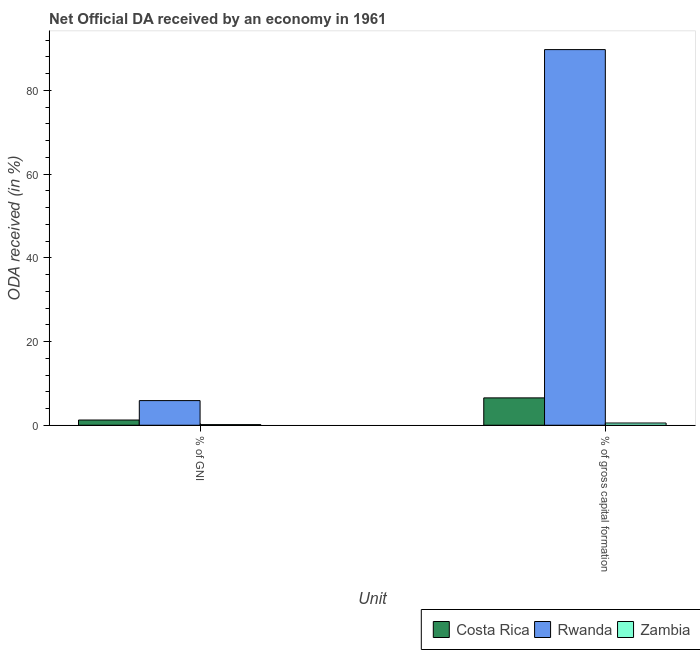How many bars are there on the 2nd tick from the left?
Ensure brevity in your answer.  3. What is the label of the 1st group of bars from the left?
Your response must be concise. % of GNI. What is the oda received as percentage of gross capital formation in Costa Rica?
Provide a short and direct response. 6.54. Across all countries, what is the maximum oda received as percentage of gni?
Make the answer very short. 5.89. Across all countries, what is the minimum oda received as percentage of gni?
Ensure brevity in your answer.  0.15. In which country was the oda received as percentage of gni maximum?
Give a very brief answer. Rwanda. In which country was the oda received as percentage of gross capital formation minimum?
Provide a short and direct response. Zambia. What is the total oda received as percentage of gross capital formation in the graph?
Provide a succinct answer. 96.82. What is the difference between the oda received as percentage of gni in Costa Rica and that in Zambia?
Offer a very short reply. 1.1. What is the difference between the oda received as percentage of gross capital formation in Costa Rica and the oda received as percentage of gni in Rwanda?
Ensure brevity in your answer.  0.65. What is the average oda received as percentage of gross capital formation per country?
Keep it short and to the point. 32.27. What is the difference between the oda received as percentage of gross capital formation and oda received as percentage of gni in Costa Rica?
Provide a short and direct response. 5.29. In how many countries, is the oda received as percentage of gross capital formation greater than 48 %?
Offer a very short reply. 1. What is the ratio of the oda received as percentage of gross capital formation in Costa Rica to that in Zambia?
Ensure brevity in your answer.  12.23. What does the 1st bar from the left in % of gross capital formation represents?
Give a very brief answer. Costa Rica. How many countries are there in the graph?
Provide a succinct answer. 3. Are the values on the major ticks of Y-axis written in scientific E-notation?
Your response must be concise. No. Where does the legend appear in the graph?
Your response must be concise. Bottom right. What is the title of the graph?
Give a very brief answer. Net Official DA received by an economy in 1961. What is the label or title of the X-axis?
Provide a succinct answer. Unit. What is the label or title of the Y-axis?
Ensure brevity in your answer.  ODA received (in %). What is the ODA received (in %) in Costa Rica in % of GNI?
Keep it short and to the point. 1.25. What is the ODA received (in %) of Rwanda in % of GNI?
Ensure brevity in your answer.  5.89. What is the ODA received (in %) of Zambia in % of GNI?
Your answer should be compact. 0.15. What is the ODA received (in %) in Costa Rica in % of gross capital formation?
Offer a very short reply. 6.54. What is the ODA received (in %) in Rwanda in % of gross capital formation?
Your answer should be compact. 89.75. What is the ODA received (in %) in Zambia in % of gross capital formation?
Ensure brevity in your answer.  0.53. Across all Unit, what is the maximum ODA received (in %) of Costa Rica?
Your answer should be very brief. 6.54. Across all Unit, what is the maximum ODA received (in %) in Rwanda?
Your answer should be very brief. 89.75. Across all Unit, what is the maximum ODA received (in %) of Zambia?
Offer a very short reply. 0.53. Across all Unit, what is the minimum ODA received (in %) of Costa Rica?
Your response must be concise. 1.25. Across all Unit, what is the minimum ODA received (in %) in Rwanda?
Ensure brevity in your answer.  5.89. Across all Unit, what is the minimum ODA received (in %) in Zambia?
Provide a short and direct response. 0.15. What is the total ODA received (in %) in Costa Rica in the graph?
Your answer should be very brief. 7.78. What is the total ODA received (in %) of Rwanda in the graph?
Your answer should be very brief. 95.64. What is the total ODA received (in %) of Zambia in the graph?
Keep it short and to the point. 0.68. What is the difference between the ODA received (in %) in Costa Rica in % of GNI and that in % of gross capital formation?
Make the answer very short. -5.29. What is the difference between the ODA received (in %) of Rwanda in % of GNI and that in % of gross capital formation?
Keep it short and to the point. -83.86. What is the difference between the ODA received (in %) of Zambia in % of GNI and that in % of gross capital formation?
Your answer should be very brief. -0.39. What is the difference between the ODA received (in %) of Costa Rica in % of GNI and the ODA received (in %) of Rwanda in % of gross capital formation?
Give a very brief answer. -88.5. What is the difference between the ODA received (in %) of Costa Rica in % of GNI and the ODA received (in %) of Zambia in % of gross capital formation?
Make the answer very short. 0.71. What is the difference between the ODA received (in %) in Rwanda in % of GNI and the ODA received (in %) in Zambia in % of gross capital formation?
Ensure brevity in your answer.  5.35. What is the average ODA received (in %) in Costa Rica per Unit?
Your answer should be compact. 3.89. What is the average ODA received (in %) of Rwanda per Unit?
Your answer should be compact. 47.82. What is the average ODA received (in %) of Zambia per Unit?
Provide a short and direct response. 0.34. What is the difference between the ODA received (in %) of Costa Rica and ODA received (in %) of Rwanda in % of GNI?
Ensure brevity in your answer.  -4.64. What is the difference between the ODA received (in %) of Costa Rica and ODA received (in %) of Zambia in % of GNI?
Provide a succinct answer. 1.1. What is the difference between the ODA received (in %) in Rwanda and ODA received (in %) in Zambia in % of GNI?
Your answer should be compact. 5.74. What is the difference between the ODA received (in %) in Costa Rica and ODA received (in %) in Rwanda in % of gross capital formation?
Your answer should be very brief. -83.21. What is the difference between the ODA received (in %) in Costa Rica and ODA received (in %) in Zambia in % of gross capital formation?
Give a very brief answer. 6. What is the difference between the ODA received (in %) of Rwanda and ODA received (in %) of Zambia in % of gross capital formation?
Provide a short and direct response. 89.22. What is the ratio of the ODA received (in %) of Costa Rica in % of GNI to that in % of gross capital formation?
Offer a terse response. 0.19. What is the ratio of the ODA received (in %) in Rwanda in % of GNI to that in % of gross capital formation?
Offer a terse response. 0.07. What is the ratio of the ODA received (in %) of Zambia in % of GNI to that in % of gross capital formation?
Your response must be concise. 0.28. What is the difference between the highest and the second highest ODA received (in %) of Costa Rica?
Ensure brevity in your answer.  5.29. What is the difference between the highest and the second highest ODA received (in %) in Rwanda?
Your response must be concise. 83.86. What is the difference between the highest and the second highest ODA received (in %) of Zambia?
Keep it short and to the point. 0.39. What is the difference between the highest and the lowest ODA received (in %) in Costa Rica?
Offer a terse response. 5.29. What is the difference between the highest and the lowest ODA received (in %) of Rwanda?
Make the answer very short. 83.86. What is the difference between the highest and the lowest ODA received (in %) of Zambia?
Keep it short and to the point. 0.39. 